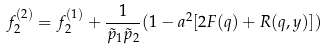<formula> <loc_0><loc_0><loc_500><loc_500>f _ { 2 } ^ { ( 2 ) } = f _ { 2 } ^ { ( 1 ) } + \frac { 1 } { \tilde { p } _ { 1 } \tilde { p } _ { 2 } } ( 1 - a ^ { 2 } [ 2 F ( q ) + R ( q , y ) ] )</formula> 